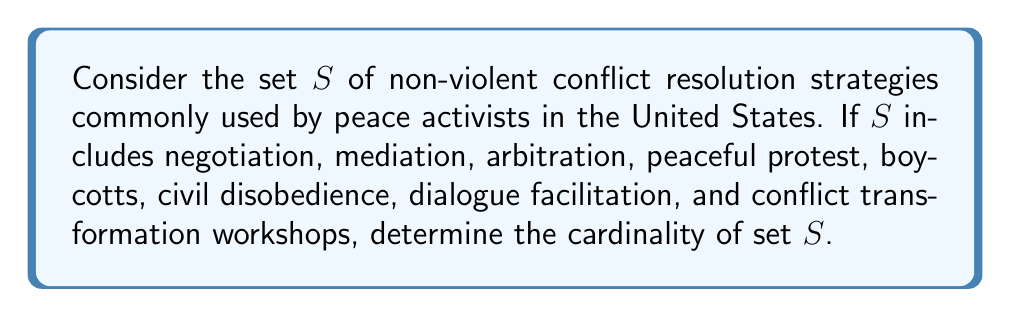Teach me how to tackle this problem. To determine the cardinality of set $S$, we need to count the number of distinct elements in the set. Let's list out the elements of set $S$:

1. Negotiation
2. Mediation
3. Arbitration
4. Peaceful protest
5. Boycotts
6. Civil disobedience
7. Dialogue facilitation
8. Conflict transformation workshops

Each of these strategies is a distinct element in the set. In set theory, the cardinality of a finite set is simply the number of elements in that set.

Therefore, to find the cardinality of set $S$, we count the number of elements listed:

$$|S| = 8$$

Where $|S|$ denotes the cardinality of set $S$.
Answer: The cardinality of set $S$ is 8. 